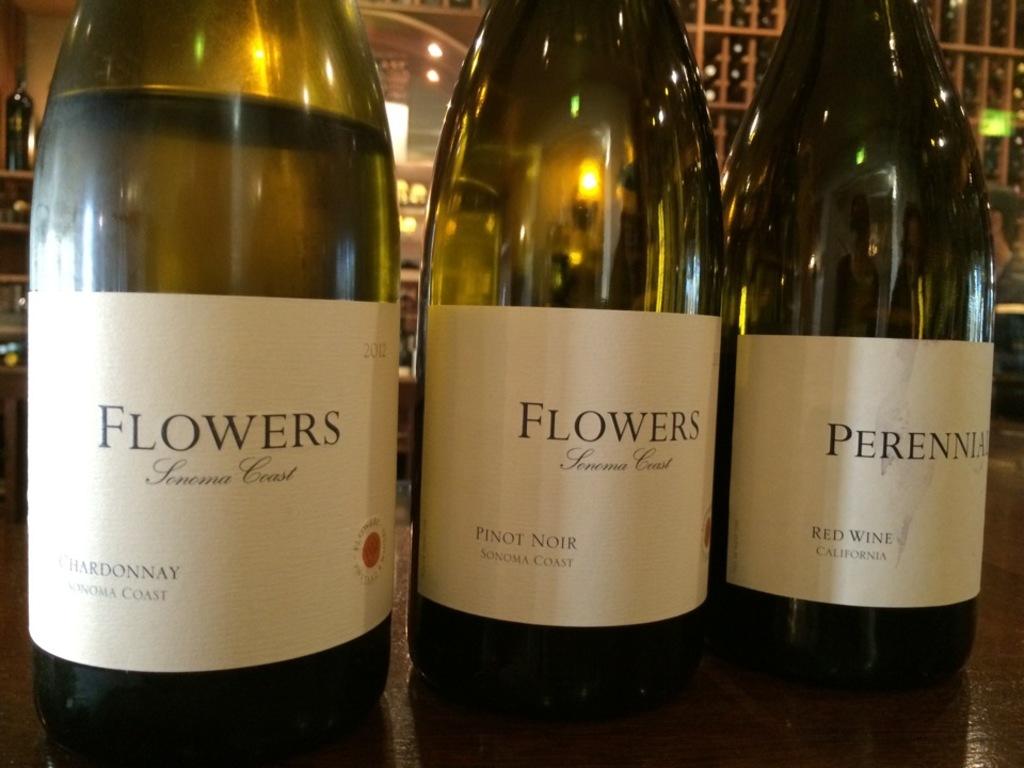What is the last the name on the last bottle to the right?
Keep it short and to the point. Perennia. 